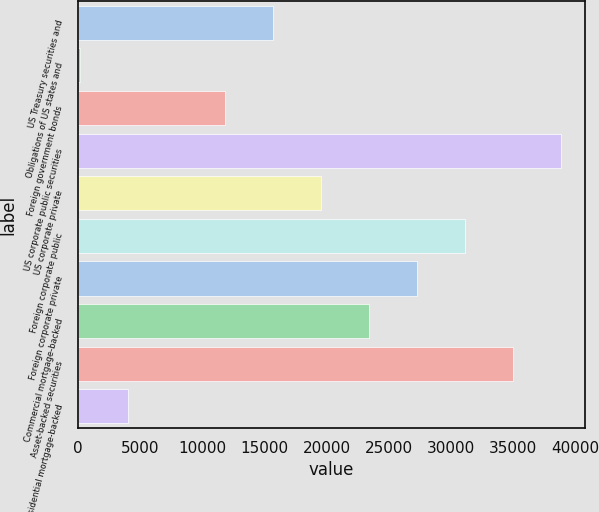Convert chart. <chart><loc_0><loc_0><loc_500><loc_500><bar_chart><fcel>US Treasury securities and<fcel>Obligations of US states and<fcel>Foreign government bonds<fcel>US corporate public securities<fcel>US corporate private<fcel>Foreign corporate public<fcel>Foreign corporate private<fcel>Commercial mortgage-backed<fcel>Asset-backed securities<fcel>Residential mortgage-backed<nl><fcel>15649.2<fcel>194<fcel>11785.4<fcel>38832<fcel>19513<fcel>31104.4<fcel>27240.6<fcel>23376.8<fcel>34968.2<fcel>4057.8<nl></chart> 